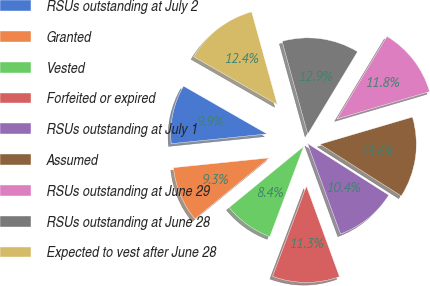<chart> <loc_0><loc_0><loc_500><loc_500><pie_chart><fcel>RSUs outstanding at July 2<fcel>Granted<fcel>Vested<fcel>Forfeited or expired<fcel>RSUs outstanding at July 1<fcel>Assumed<fcel>RSUs outstanding at June 29<fcel>RSUs outstanding at June 28<fcel>Expected to vest after June 28<nl><fcel>9.9%<fcel>9.31%<fcel>8.36%<fcel>11.28%<fcel>10.42%<fcel>13.57%<fcel>11.8%<fcel>12.94%<fcel>12.42%<nl></chart> 